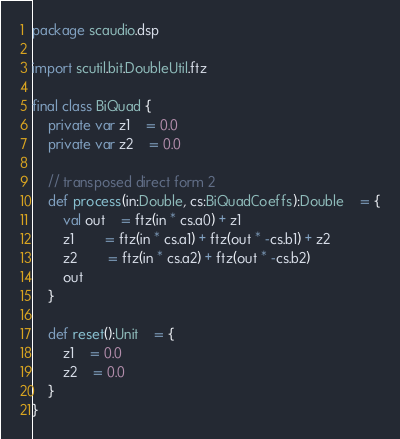Convert code to text. <code><loc_0><loc_0><loc_500><loc_500><_Scala_>package scaudio.dsp

import scutil.bit.DoubleUtil.ftz

final class BiQuad {
	private var z1	= 0.0
	private var z2	= 0.0

	// transposed direct form 2
	def process(in:Double, cs:BiQuadCoeffs):Double	= {
		val out	= ftz(in * cs.a0) + z1
		z1		= ftz(in * cs.a1) + ftz(out * -cs.b1) + z2
		z2		= ftz(in * cs.a2) + ftz(out * -cs.b2)
		out
	}

	def reset():Unit	= {
		z1	= 0.0
		z2	= 0.0
	}
}
</code> 